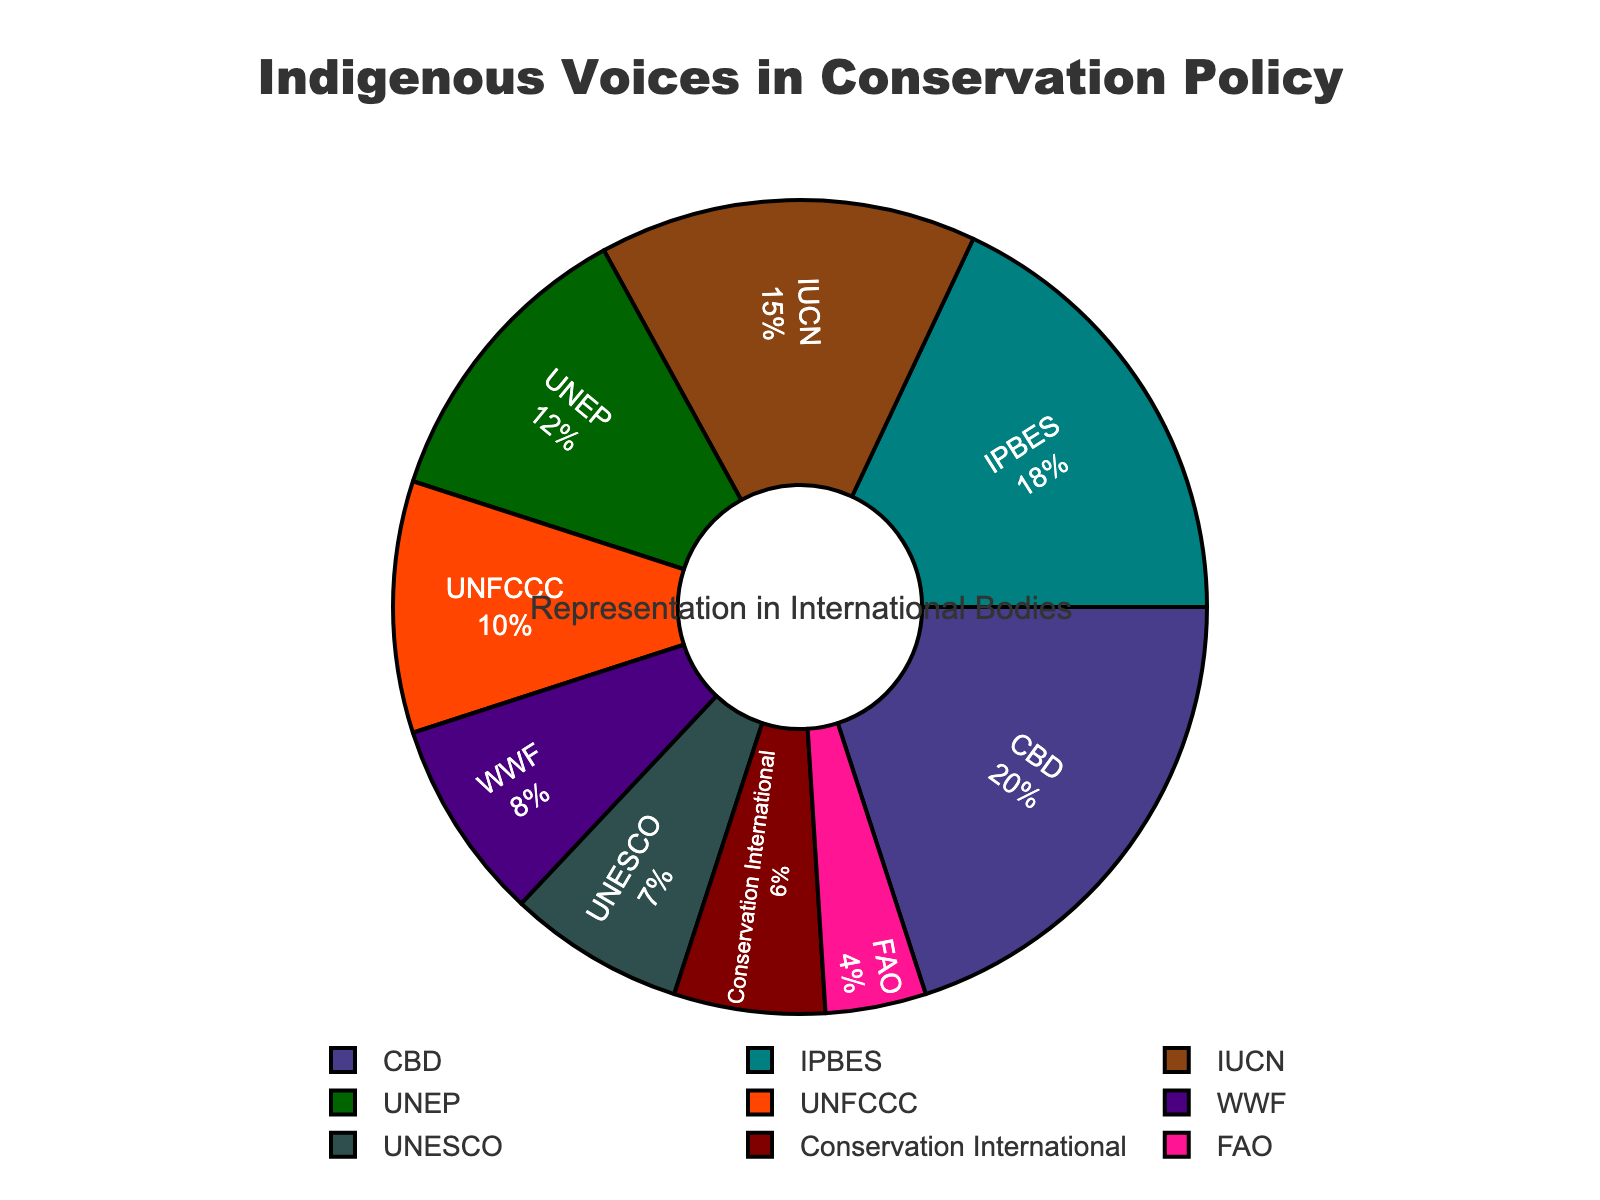What percentage of representation do the top three organizations cumulatively contribute? First, identify the top three organizations: CBD (20%), IPBES (18%), and IUCN (15%). Then, sum their percentages: 20 + 18 + 15 = 53.
Answer: 53% Which organization has the least representation in the conservation policy-making bodies? The organization with the lowest percentage is FAO at 4%.
Answer: FAO What is the difference in representation between the organization with the highest representation and the organization with the lowest representation? The organization with the highest representation is CBD (20%), and the one with the lowest is FAO (4%). The difference is 20 - 4 = 16.
Answer: 16 Compare the representation between UNESCO and WWF. Which one has a higher representation, and by how much? UNESCO has 7%, and WWF has 8%. WWF has a higher representation by 8 - 7 = 1.
Answer: WWF by 1% If you combine the representation percentages of UNEP, Conservation International, and UNFCCC, what will the total percentage be? Sum the percentages of UNEP (12%), Conservation International (6%), and UNFCCC (10%): 12 + 6 + 10 = 28.
Answer: 28% How does the representation of IPBES compare to that of the IUCN? IPBES (18%) has a higher representation than IUCN (15%).
Answer: IPBES What's the average representation percentage across all organizations? Sum the percentages of all organizations: 15 + 12 + 8 + 6 + 18 + 20 + 10 + 7 + 4 = 100. There are 9 organizations, so the average is 100 / 9 ≈ 11.11.
Answer: 11.11 Among the organizations displayed, which ones have a representation of 10% or higher? The organizations with representation of 10% or higher are IUCN (15%), UNEP (12%), IPBES (18%), CBD (20%), and UNFCCC (10%).
Answer: IUCN, UNEP, IPBES, CBD, UNFCCC What fraction of the total representation is provided by UNESCO and FAO combined? Combine the percentages of UNESCO (7%) and FAO (4%): 7 + 4 = 11. To find the fraction, divide by the total of 100: 11 / 100 = 0.11 or 11/100.
Answer: 11/100 